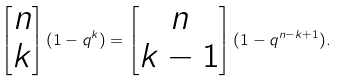<formula> <loc_0><loc_0><loc_500><loc_500>\begin{bmatrix} n \\ k \end{bmatrix} ( 1 - q ^ { k } ) = \begin{bmatrix} n \\ k - 1 \end{bmatrix} ( 1 - q ^ { n - k + 1 } ) .</formula> 